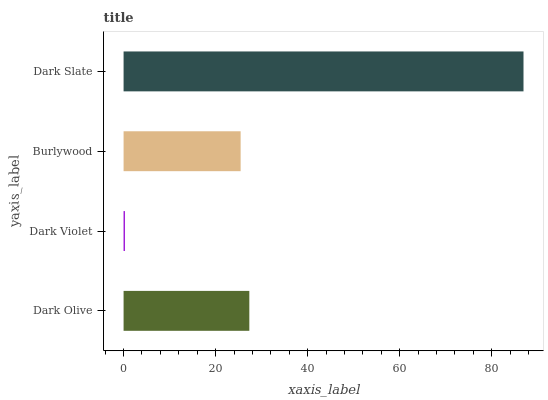Is Dark Violet the minimum?
Answer yes or no. Yes. Is Dark Slate the maximum?
Answer yes or no. Yes. Is Burlywood the minimum?
Answer yes or no. No. Is Burlywood the maximum?
Answer yes or no. No. Is Burlywood greater than Dark Violet?
Answer yes or no. Yes. Is Dark Violet less than Burlywood?
Answer yes or no. Yes. Is Dark Violet greater than Burlywood?
Answer yes or no. No. Is Burlywood less than Dark Violet?
Answer yes or no. No. Is Dark Olive the high median?
Answer yes or no. Yes. Is Burlywood the low median?
Answer yes or no. Yes. Is Burlywood the high median?
Answer yes or no. No. Is Dark Slate the low median?
Answer yes or no. No. 